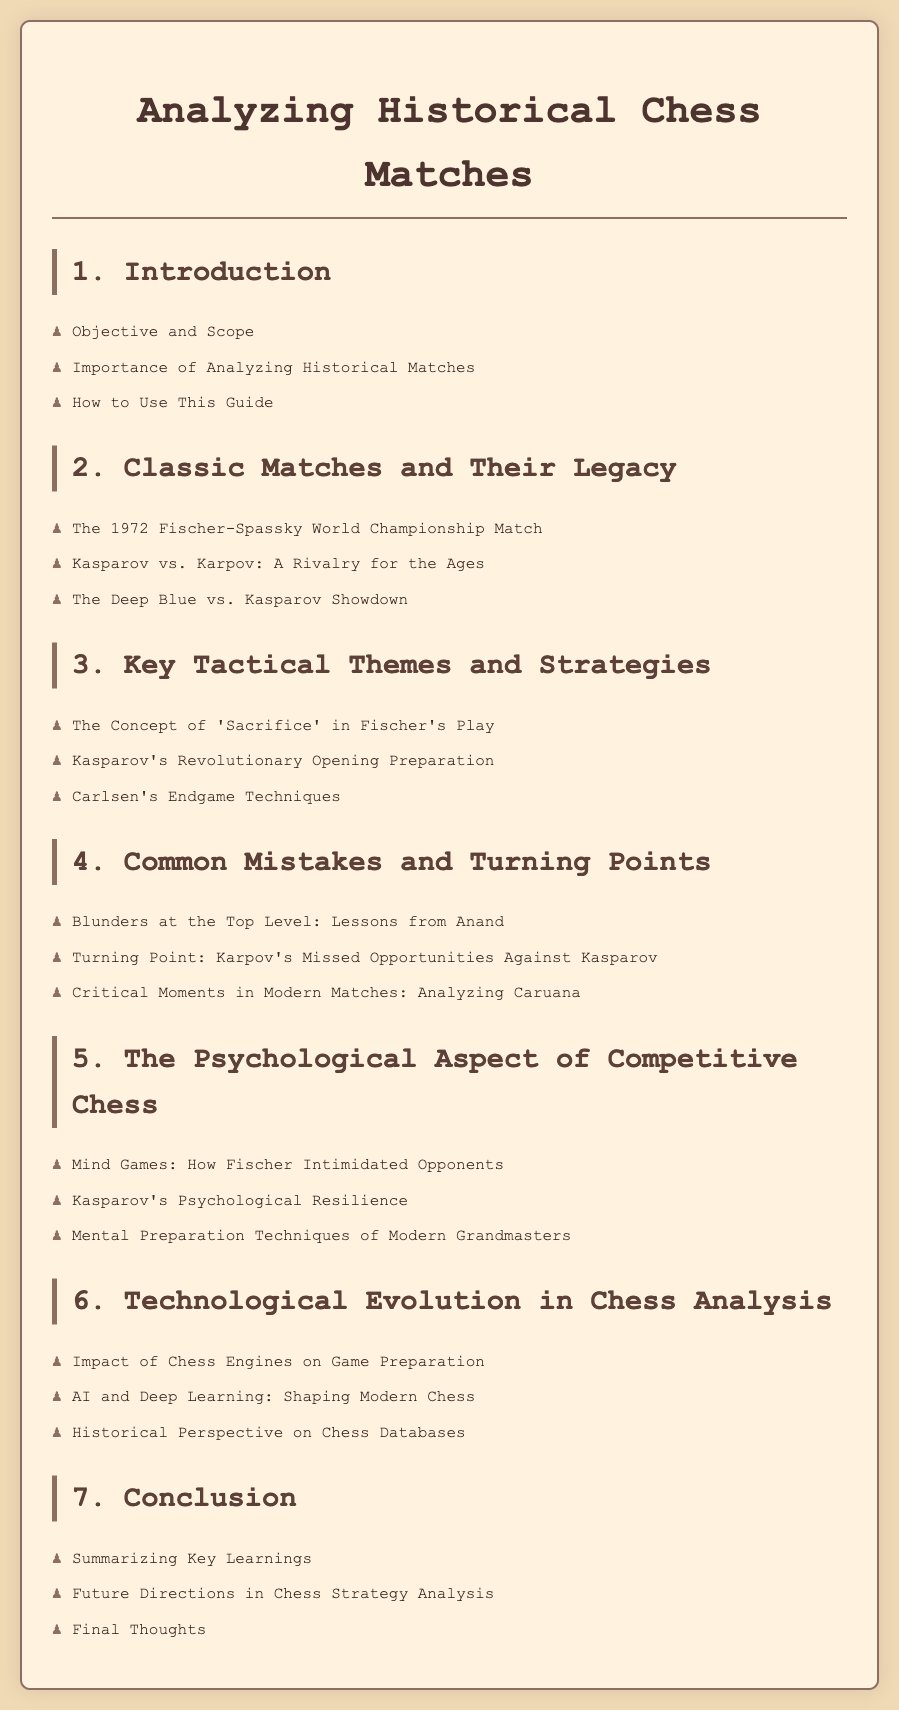What is the main objective of the document? The introduction section outlines the objective of the document, which is to analyze historical chess matches.
Answer: Analyzing historical chess matches Who competed in the 1972 World Championship Match? The document specifies the key players in this classic match.
Answer: Fischer and Spassky What is a key tactical theme mentioned for Fischer's play? The document highlights the concept used by Fischer in his strategies.
Answer: Sacrifice Which player is noted for their psychological resilience? The psychological aspect section identifies a player known for this trait.
Answer: Kasparov How many key sections are there in the document? The list of headings reveals the number of distinct sections covered.
Answer: Seven 